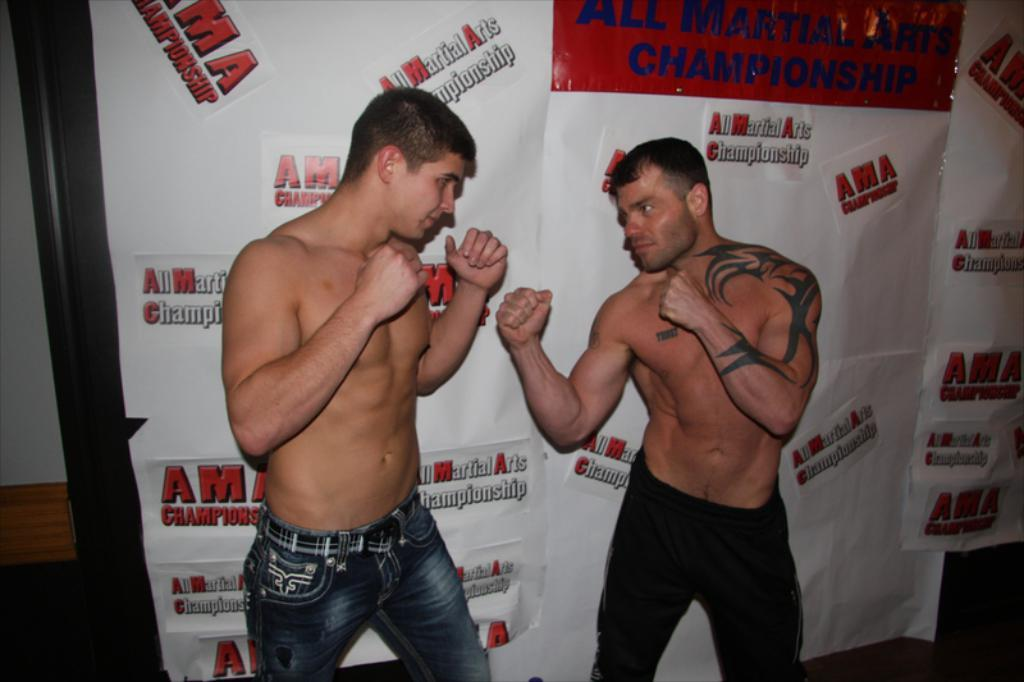How many people are in the image? There are two persons in the image. What are the persons doing in the image? The persons are in a fighting position. What can be seen in the background of the image? There are posters and a part of the wall visible in the background of the image. What type of shoes are the persons wearing in the image? There is no information about shoes in the image, as the focus is on the persons' fighting position and the background elements. 